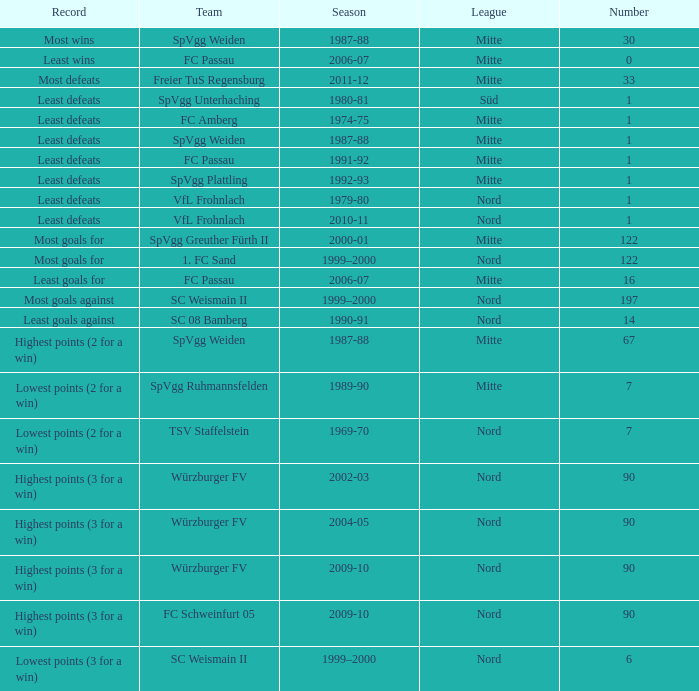Which league boasts the record for the greatest number of wins? Mitte. Could you help me parse every detail presented in this table? {'header': ['Record', 'Team', 'Season', 'League', 'Number'], 'rows': [['Most wins', 'SpVgg Weiden', '1987-88', 'Mitte', '30'], ['Least wins', 'FC Passau', '2006-07', 'Mitte', '0'], ['Most defeats', 'Freier TuS Regensburg', '2011-12', 'Mitte', '33'], ['Least defeats', 'SpVgg Unterhaching', '1980-81', 'Süd', '1'], ['Least defeats', 'FC Amberg', '1974-75', 'Mitte', '1'], ['Least defeats', 'SpVgg Weiden', '1987-88', 'Mitte', '1'], ['Least defeats', 'FC Passau', '1991-92', 'Mitte', '1'], ['Least defeats', 'SpVgg Plattling', '1992-93', 'Mitte', '1'], ['Least defeats', 'VfL Frohnlach', '1979-80', 'Nord', '1'], ['Least defeats', 'VfL Frohnlach', '2010-11', 'Nord', '1'], ['Most goals for', 'SpVgg Greuther Fürth II', '2000-01', 'Mitte', '122'], ['Most goals for', '1. FC Sand', '1999–2000', 'Nord', '122'], ['Least goals for', 'FC Passau', '2006-07', 'Mitte', '16'], ['Most goals against', 'SC Weismain II', '1999–2000', 'Nord', '197'], ['Least goals against', 'SC 08 Bamberg', '1990-91', 'Nord', '14'], ['Highest points (2 for a win)', 'SpVgg Weiden', '1987-88', 'Mitte', '67'], ['Lowest points (2 for a win)', 'SpVgg Ruhmannsfelden', '1989-90', 'Mitte', '7'], ['Lowest points (2 for a win)', 'TSV Staffelstein', '1969-70', 'Nord', '7'], ['Highest points (3 for a win)', 'Würzburger FV', '2002-03', 'Nord', '90'], ['Highest points (3 for a win)', 'Würzburger FV', '2004-05', 'Nord', '90'], ['Highest points (3 for a win)', 'Würzburger FV', '2009-10', 'Nord', '90'], ['Highest points (3 for a win)', 'FC Schweinfurt 05', '2009-10', 'Nord', '90'], ['Lowest points (3 for a win)', 'SC Weismain II', '1999–2000', 'Nord', '6']]} 